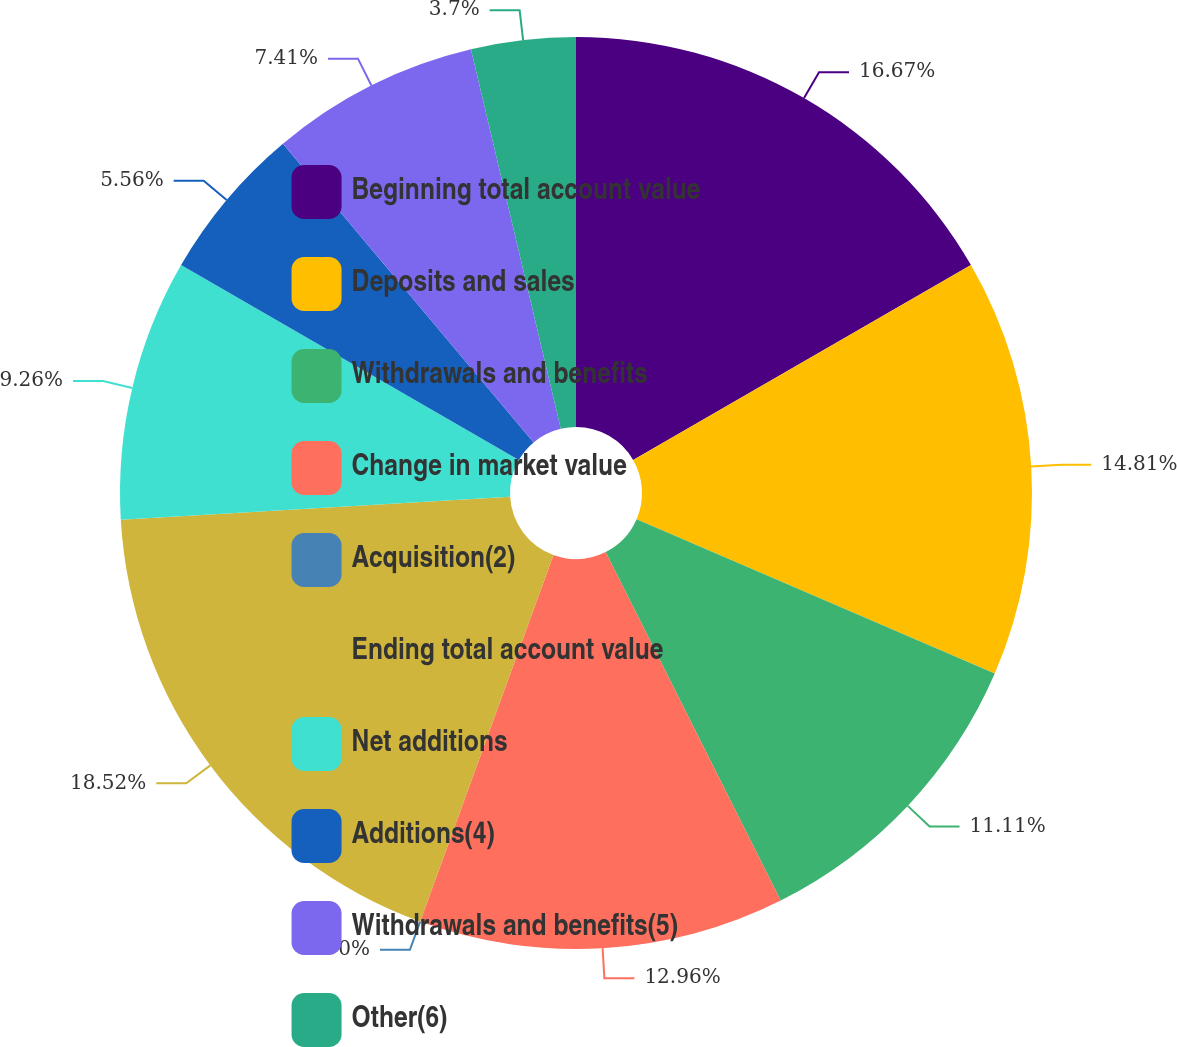Convert chart to OTSL. <chart><loc_0><loc_0><loc_500><loc_500><pie_chart><fcel>Beginning total account value<fcel>Deposits and sales<fcel>Withdrawals and benefits<fcel>Change in market value<fcel>Acquisition(2)<fcel>Ending total account value<fcel>Net additions<fcel>Additions(4)<fcel>Withdrawals and benefits(5)<fcel>Other(6)<nl><fcel>16.67%<fcel>14.81%<fcel>11.11%<fcel>12.96%<fcel>0.0%<fcel>18.52%<fcel>9.26%<fcel>5.56%<fcel>7.41%<fcel>3.7%<nl></chart> 